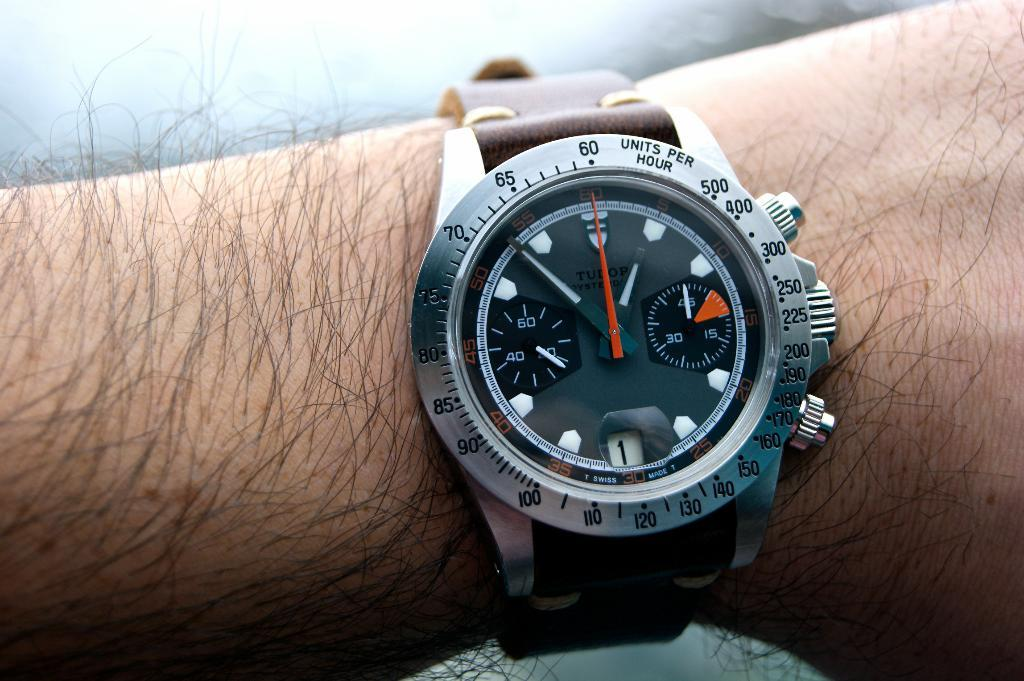<image>
Give a short and clear explanation of the subsequent image. A watch has the words units per hour on the side of the face. 